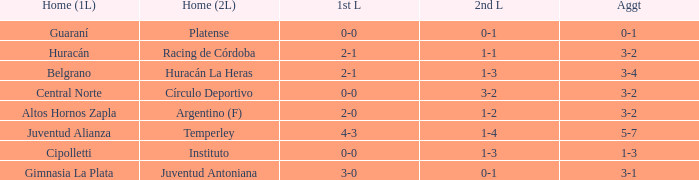In which team's favor was the 3-2 aggregate score after a 1-1 draw in the 2nd leg at home? Racing de Córdoba. 